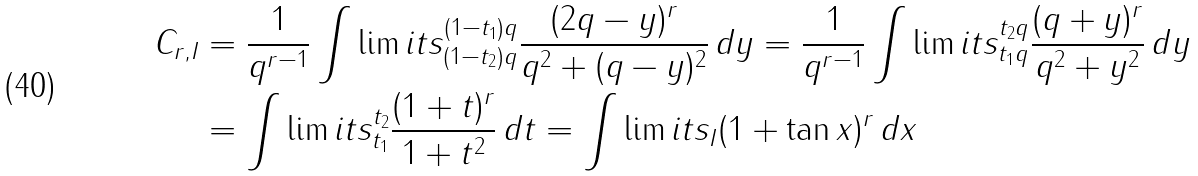<formula> <loc_0><loc_0><loc_500><loc_500>C _ { r , I } & = \frac { 1 } { q ^ { r - 1 } } \int \lim i t s _ { ( 1 - t _ { 2 } ) q } ^ { ( 1 - t _ { 1 } ) q } \frac { ( 2 q - y ) ^ { r } } { q ^ { 2 } + ( q - y ) ^ { 2 } } \, d y = \frac { 1 } { q ^ { r - 1 } } \int \lim i t s _ { t _ { 1 } q } ^ { t _ { 2 } q } \frac { ( q + y ) ^ { r } } { q ^ { 2 } + y ^ { 2 } } \, d y \\ & = \int \lim i t s _ { t _ { 1 } } ^ { t _ { 2 } } \frac { ( 1 + t ) ^ { r } } { 1 + t ^ { 2 } } \, d t = \int \lim i t s _ { I } ( 1 + \tan x ) ^ { r } \, d x</formula> 